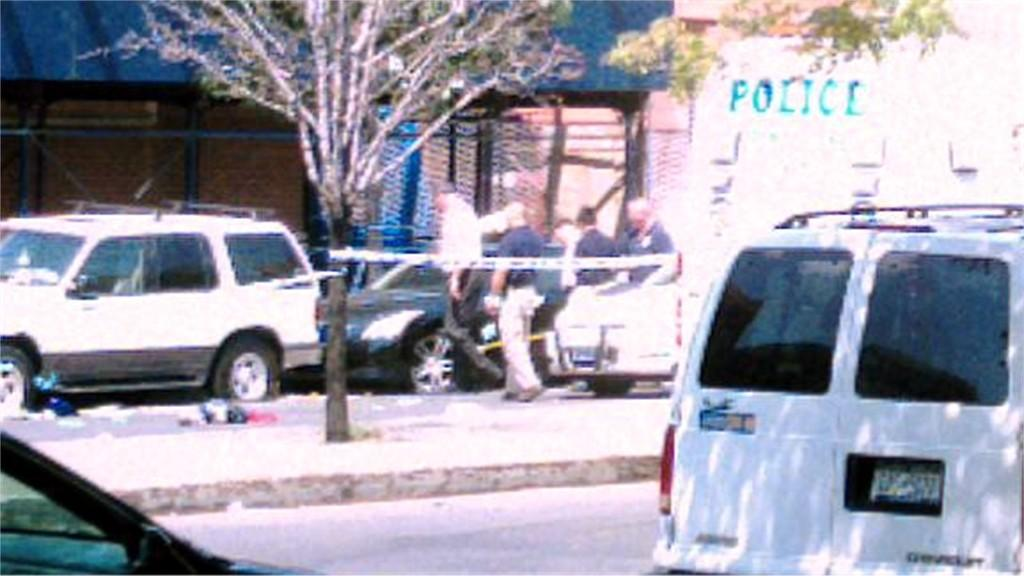<image>
Present a compact description of the photo's key features. The police van can be seen in the background. 